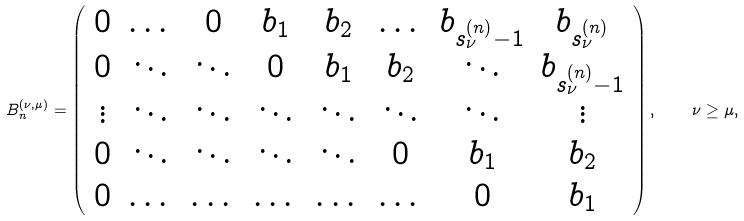Convert formula to latex. <formula><loc_0><loc_0><loc_500><loc_500>B _ { n } ^ { ( \nu , \mu ) } = \left ( \begin{array} { c c c c c c c c } 0 & \dots & 0 & b _ { 1 } & b _ { 2 } & \dots & b _ { s _ { \nu } ^ { ( n ) } - 1 } & b _ { s _ { \nu } ^ { ( n ) } } \\ 0 & \ddots & \ddots & 0 & b _ { 1 } & b _ { 2 } & \ddots & b _ { s _ { \nu } ^ { ( n ) } - 1 } \\ \vdots & \ddots & \ddots & \ddots & \ddots & \ddots & \ddots & \vdots \\ 0 & \ddots & \ddots & \ddots & \ddots & 0 & b _ { 1 } & b _ { 2 } \\ 0 & \dots & \dots & \dots & \dots & \dots & 0 & b _ { 1 } \end{array} \right ) , \quad \nu \geq \mu ,</formula> 